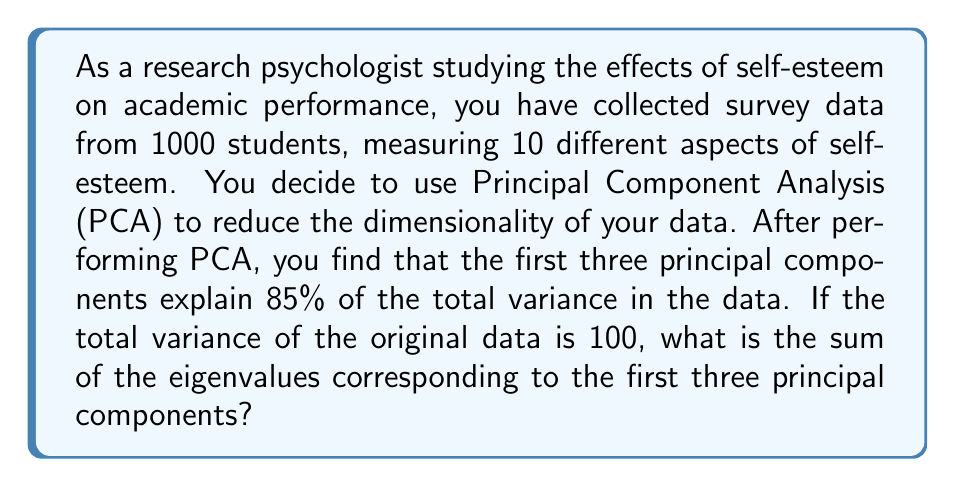Give your solution to this math problem. To solve this problem, we need to understand the relationship between eigenvalues, explained variance, and total variance in PCA:

1) In PCA, each principal component is associated with an eigenvalue that represents the amount of variance explained by that component.

2) The sum of all eigenvalues equals the total variance in the original data.

3) The proportion of variance explained by a set of principal components is equal to the sum of their corresponding eigenvalues divided by the total variance.

Let's approach this step-by-step:

1) We're told that the total variance of the original data is 100.

2) The first three principal components explain 85% of the total variance.

3) Let $\lambda_1$, $\lambda_2$, and $\lambda_3$ be the eigenvalues corresponding to the first three principal components.

4) We can set up the following equation:

   $$\frac{\lambda_1 + \lambda_2 + \lambda_3}{100} = 0.85$$

5) Solving for the sum of the eigenvalues:

   $$\lambda_1 + \lambda_2 + \lambda_3 = 0.85 \times 100 = 85$$

Therefore, the sum of the eigenvalues corresponding to the first three principal components is 85.
Answer: 85 